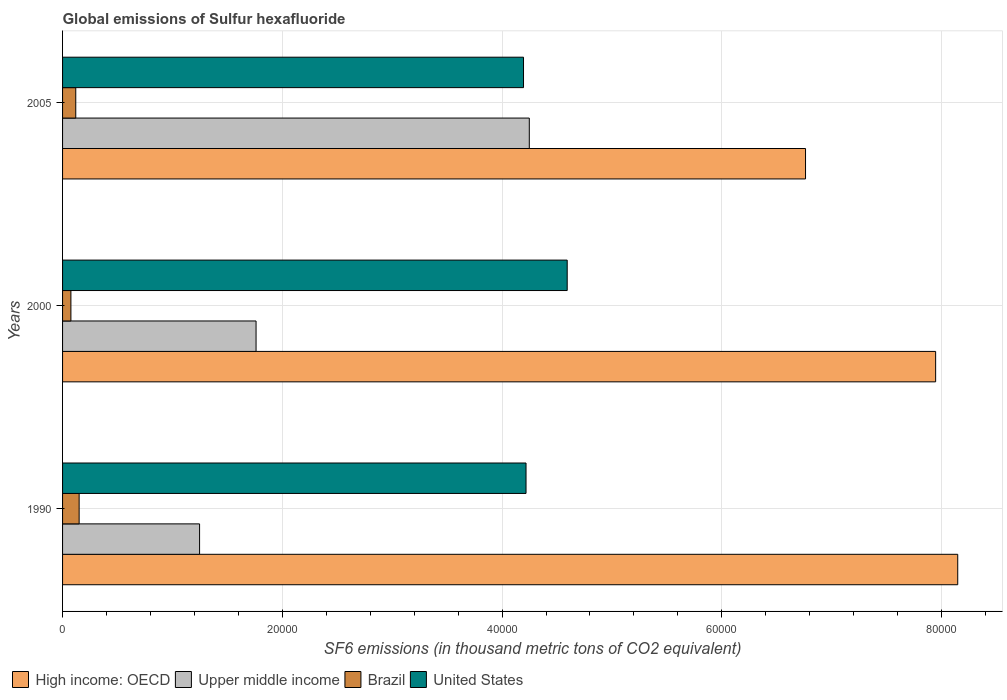How many different coloured bars are there?
Your answer should be compact. 4. Are the number of bars on each tick of the Y-axis equal?
Provide a short and direct response. Yes. What is the global emissions of Sulfur hexafluoride in Upper middle income in 2005?
Make the answer very short. 4.25e+04. Across all years, what is the maximum global emissions of Sulfur hexafluoride in United States?
Ensure brevity in your answer.  4.59e+04. Across all years, what is the minimum global emissions of Sulfur hexafluoride in High income: OECD?
Provide a succinct answer. 6.76e+04. In which year was the global emissions of Sulfur hexafluoride in Upper middle income maximum?
Offer a very short reply. 2005. In which year was the global emissions of Sulfur hexafluoride in United States minimum?
Your answer should be very brief. 2005. What is the total global emissions of Sulfur hexafluoride in Brazil in the graph?
Provide a short and direct response. 3468.6. What is the difference between the global emissions of Sulfur hexafluoride in United States in 2000 and that in 2005?
Your response must be concise. 3977.2. What is the difference between the global emissions of Sulfur hexafluoride in United States in 2005 and the global emissions of Sulfur hexafluoride in Upper middle income in 2000?
Offer a terse response. 2.43e+04. What is the average global emissions of Sulfur hexafluoride in Brazil per year?
Your answer should be compact. 1156.2. In the year 2000, what is the difference between the global emissions of Sulfur hexafluoride in Brazil and global emissions of Sulfur hexafluoride in United States?
Your response must be concise. -4.52e+04. In how many years, is the global emissions of Sulfur hexafluoride in High income: OECD greater than 8000 thousand metric tons?
Provide a short and direct response. 3. What is the ratio of the global emissions of Sulfur hexafluoride in High income: OECD in 1990 to that in 2005?
Offer a terse response. 1.2. Is the global emissions of Sulfur hexafluoride in United States in 1990 less than that in 2000?
Provide a short and direct response. Yes. Is the difference between the global emissions of Sulfur hexafluoride in Brazil in 1990 and 2000 greater than the difference between the global emissions of Sulfur hexafluoride in United States in 1990 and 2000?
Your response must be concise. Yes. What is the difference between the highest and the second highest global emissions of Sulfur hexafluoride in Upper middle income?
Keep it short and to the point. 2.49e+04. What is the difference between the highest and the lowest global emissions of Sulfur hexafluoride in United States?
Provide a short and direct response. 3977.2. What does the 4th bar from the top in 1990 represents?
Provide a succinct answer. High income: OECD. What does the 3rd bar from the bottom in 2000 represents?
Offer a terse response. Brazil. Is it the case that in every year, the sum of the global emissions of Sulfur hexafluoride in High income: OECD and global emissions of Sulfur hexafluoride in Upper middle income is greater than the global emissions of Sulfur hexafluoride in Brazil?
Keep it short and to the point. Yes. How many bars are there?
Your response must be concise. 12. Are all the bars in the graph horizontal?
Your answer should be very brief. Yes. How many years are there in the graph?
Offer a very short reply. 3. What is the difference between two consecutive major ticks on the X-axis?
Ensure brevity in your answer.  2.00e+04. Where does the legend appear in the graph?
Offer a terse response. Bottom left. How many legend labels are there?
Keep it short and to the point. 4. What is the title of the graph?
Give a very brief answer. Global emissions of Sulfur hexafluoride. Does "Ukraine" appear as one of the legend labels in the graph?
Provide a short and direct response. No. What is the label or title of the X-axis?
Give a very brief answer. SF6 emissions (in thousand metric tons of CO2 equivalent). What is the label or title of the Y-axis?
Provide a short and direct response. Years. What is the SF6 emissions (in thousand metric tons of CO2 equivalent) in High income: OECD in 1990?
Your response must be concise. 8.15e+04. What is the SF6 emissions (in thousand metric tons of CO2 equivalent) of Upper middle income in 1990?
Your answer should be compact. 1.25e+04. What is the SF6 emissions (in thousand metric tons of CO2 equivalent) of Brazil in 1990?
Make the answer very short. 1507.9. What is the SF6 emissions (in thousand metric tons of CO2 equivalent) of United States in 1990?
Give a very brief answer. 4.22e+04. What is the SF6 emissions (in thousand metric tons of CO2 equivalent) of High income: OECD in 2000?
Make the answer very short. 7.95e+04. What is the SF6 emissions (in thousand metric tons of CO2 equivalent) in Upper middle income in 2000?
Provide a short and direct response. 1.76e+04. What is the SF6 emissions (in thousand metric tons of CO2 equivalent) of Brazil in 2000?
Your answer should be very brief. 758.7. What is the SF6 emissions (in thousand metric tons of CO2 equivalent) of United States in 2000?
Offer a terse response. 4.59e+04. What is the SF6 emissions (in thousand metric tons of CO2 equivalent) in High income: OECD in 2005?
Your answer should be compact. 6.76e+04. What is the SF6 emissions (in thousand metric tons of CO2 equivalent) in Upper middle income in 2005?
Ensure brevity in your answer.  4.25e+04. What is the SF6 emissions (in thousand metric tons of CO2 equivalent) in Brazil in 2005?
Your answer should be very brief. 1202. What is the SF6 emissions (in thousand metric tons of CO2 equivalent) of United States in 2005?
Offer a terse response. 4.20e+04. Across all years, what is the maximum SF6 emissions (in thousand metric tons of CO2 equivalent) of High income: OECD?
Offer a terse response. 8.15e+04. Across all years, what is the maximum SF6 emissions (in thousand metric tons of CO2 equivalent) of Upper middle income?
Offer a terse response. 4.25e+04. Across all years, what is the maximum SF6 emissions (in thousand metric tons of CO2 equivalent) of Brazil?
Keep it short and to the point. 1507.9. Across all years, what is the maximum SF6 emissions (in thousand metric tons of CO2 equivalent) in United States?
Your response must be concise. 4.59e+04. Across all years, what is the minimum SF6 emissions (in thousand metric tons of CO2 equivalent) of High income: OECD?
Your answer should be very brief. 6.76e+04. Across all years, what is the minimum SF6 emissions (in thousand metric tons of CO2 equivalent) of Upper middle income?
Make the answer very short. 1.25e+04. Across all years, what is the minimum SF6 emissions (in thousand metric tons of CO2 equivalent) in Brazil?
Offer a terse response. 758.7. Across all years, what is the minimum SF6 emissions (in thousand metric tons of CO2 equivalent) of United States?
Keep it short and to the point. 4.20e+04. What is the total SF6 emissions (in thousand metric tons of CO2 equivalent) in High income: OECD in the graph?
Offer a terse response. 2.29e+05. What is the total SF6 emissions (in thousand metric tons of CO2 equivalent) of Upper middle income in the graph?
Your response must be concise. 7.26e+04. What is the total SF6 emissions (in thousand metric tons of CO2 equivalent) in Brazil in the graph?
Offer a terse response. 3468.6. What is the total SF6 emissions (in thousand metric tons of CO2 equivalent) in United States in the graph?
Make the answer very short. 1.30e+05. What is the difference between the SF6 emissions (in thousand metric tons of CO2 equivalent) in High income: OECD in 1990 and that in 2000?
Provide a short and direct response. 2011.1. What is the difference between the SF6 emissions (in thousand metric tons of CO2 equivalent) of Upper middle income in 1990 and that in 2000?
Make the answer very short. -5140.8. What is the difference between the SF6 emissions (in thousand metric tons of CO2 equivalent) of Brazil in 1990 and that in 2000?
Keep it short and to the point. 749.2. What is the difference between the SF6 emissions (in thousand metric tons of CO2 equivalent) of United States in 1990 and that in 2000?
Offer a very short reply. -3747.6. What is the difference between the SF6 emissions (in thousand metric tons of CO2 equivalent) of High income: OECD in 1990 and that in 2005?
Give a very brief answer. 1.39e+04. What is the difference between the SF6 emissions (in thousand metric tons of CO2 equivalent) of Upper middle income in 1990 and that in 2005?
Your answer should be compact. -3.00e+04. What is the difference between the SF6 emissions (in thousand metric tons of CO2 equivalent) in Brazil in 1990 and that in 2005?
Your response must be concise. 305.9. What is the difference between the SF6 emissions (in thousand metric tons of CO2 equivalent) in United States in 1990 and that in 2005?
Offer a very short reply. 229.6. What is the difference between the SF6 emissions (in thousand metric tons of CO2 equivalent) in High income: OECD in 2000 and that in 2005?
Provide a succinct answer. 1.18e+04. What is the difference between the SF6 emissions (in thousand metric tons of CO2 equivalent) in Upper middle income in 2000 and that in 2005?
Provide a short and direct response. -2.49e+04. What is the difference between the SF6 emissions (in thousand metric tons of CO2 equivalent) in Brazil in 2000 and that in 2005?
Your answer should be compact. -443.3. What is the difference between the SF6 emissions (in thousand metric tons of CO2 equivalent) in United States in 2000 and that in 2005?
Your answer should be compact. 3977.2. What is the difference between the SF6 emissions (in thousand metric tons of CO2 equivalent) in High income: OECD in 1990 and the SF6 emissions (in thousand metric tons of CO2 equivalent) in Upper middle income in 2000?
Keep it short and to the point. 6.39e+04. What is the difference between the SF6 emissions (in thousand metric tons of CO2 equivalent) in High income: OECD in 1990 and the SF6 emissions (in thousand metric tons of CO2 equivalent) in Brazil in 2000?
Your answer should be compact. 8.07e+04. What is the difference between the SF6 emissions (in thousand metric tons of CO2 equivalent) in High income: OECD in 1990 and the SF6 emissions (in thousand metric tons of CO2 equivalent) in United States in 2000?
Offer a very short reply. 3.55e+04. What is the difference between the SF6 emissions (in thousand metric tons of CO2 equivalent) of Upper middle income in 1990 and the SF6 emissions (in thousand metric tons of CO2 equivalent) of Brazil in 2000?
Offer a terse response. 1.17e+04. What is the difference between the SF6 emissions (in thousand metric tons of CO2 equivalent) of Upper middle income in 1990 and the SF6 emissions (in thousand metric tons of CO2 equivalent) of United States in 2000?
Offer a terse response. -3.35e+04. What is the difference between the SF6 emissions (in thousand metric tons of CO2 equivalent) of Brazil in 1990 and the SF6 emissions (in thousand metric tons of CO2 equivalent) of United States in 2000?
Give a very brief answer. -4.44e+04. What is the difference between the SF6 emissions (in thousand metric tons of CO2 equivalent) of High income: OECD in 1990 and the SF6 emissions (in thousand metric tons of CO2 equivalent) of Upper middle income in 2005?
Ensure brevity in your answer.  3.90e+04. What is the difference between the SF6 emissions (in thousand metric tons of CO2 equivalent) of High income: OECD in 1990 and the SF6 emissions (in thousand metric tons of CO2 equivalent) of Brazil in 2005?
Ensure brevity in your answer.  8.03e+04. What is the difference between the SF6 emissions (in thousand metric tons of CO2 equivalent) of High income: OECD in 1990 and the SF6 emissions (in thousand metric tons of CO2 equivalent) of United States in 2005?
Provide a short and direct response. 3.95e+04. What is the difference between the SF6 emissions (in thousand metric tons of CO2 equivalent) of Upper middle income in 1990 and the SF6 emissions (in thousand metric tons of CO2 equivalent) of Brazil in 2005?
Ensure brevity in your answer.  1.13e+04. What is the difference between the SF6 emissions (in thousand metric tons of CO2 equivalent) in Upper middle income in 1990 and the SF6 emissions (in thousand metric tons of CO2 equivalent) in United States in 2005?
Offer a terse response. -2.95e+04. What is the difference between the SF6 emissions (in thousand metric tons of CO2 equivalent) of Brazil in 1990 and the SF6 emissions (in thousand metric tons of CO2 equivalent) of United States in 2005?
Ensure brevity in your answer.  -4.04e+04. What is the difference between the SF6 emissions (in thousand metric tons of CO2 equivalent) in High income: OECD in 2000 and the SF6 emissions (in thousand metric tons of CO2 equivalent) in Upper middle income in 2005?
Ensure brevity in your answer.  3.70e+04. What is the difference between the SF6 emissions (in thousand metric tons of CO2 equivalent) of High income: OECD in 2000 and the SF6 emissions (in thousand metric tons of CO2 equivalent) of Brazil in 2005?
Your answer should be compact. 7.83e+04. What is the difference between the SF6 emissions (in thousand metric tons of CO2 equivalent) in High income: OECD in 2000 and the SF6 emissions (in thousand metric tons of CO2 equivalent) in United States in 2005?
Provide a short and direct response. 3.75e+04. What is the difference between the SF6 emissions (in thousand metric tons of CO2 equivalent) in Upper middle income in 2000 and the SF6 emissions (in thousand metric tons of CO2 equivalent) in Brazil in 2005?
Your answer should be compact. 1.64e+04. What is the difference between the SF6 emissions (in thousand metric tons of CO2 equivalent) in Upper middle income in 2000 and the SF6 emissions (in thousand metric tons of CO2 equivalent) in United States in 2005?
Your answer should be very brief. -2.43e+04. What is the difference between the SF6 emissions (in thousand metric tons of CO2 equivalent) in Brazil in 2000 and the SF6 emissions (in thousand metric tons of CO2 equivalent) in United States in 2005?
Offer a very short reply. -4.12e+04. What is the average SF6 emissions (in thousand metric tons of CO2 equivalent) in High income: OECD per year?
Your response must be concise. 7.62e+04. What is the average SF6 emissions (in thousand metric tons of CO2 equivalent) in Upper middle income per year?
Make the answer very short. 2.42e+04. What is the average SF6 emissions (in thousand metric tons of CO2 equivalent) in Brazil per year?
Offer a very short reply. 1156.2. What is the average SF6 emissions (in thousand metric tons of CO2 equivalent) in United States per year?
Give a very brief answer. 4.34e+04. In the year 1990, what is the difference between the SF6 emissions (in thousand metric tons of CO2 equivalent) in High income: OECD and SF6 emissions (in thousand metric tons of CO2 equivalent) in Upper middle income?
Make the answer very short. 6.90e+04. In the year 1990, what is the difference between the SF6 emissions (in thousand metric tons of CO2 equivalent) of High income: OECD and SF6 emissions (in thousand metric tons of CO2 equivalent) of Brazil?
Keep it short and to the point. 8.00e+04. In the year 1990, what is the difference between the SF6 emissions (in thousand metric tons of CO2 equivalent) of High income: OECD and SF6 emissions (in thousand metric tons of CO2 equivalent) of United States?
Offer a terse response. 3.93e+04. In the year 1990, what is the difference between the SF6 emissions (in thousand metric tons of CO2 equivalent) of Upper middle income and SF6 emissions (in thousand metric tons of CO2 equivalent) of Brazil?
Your answer should be compact. 1.10e+04. In the year 1990, what is the difference between the SF6 emissions (in thousand metric tons of CO2 equivalent) of Upper middle income and SF6 emissions (in thousand metric tons of CO2 equivalent) of United States?
Your response must be concise. -2.97e+04. In the year 1990, what is the difference between the SF6 emissions (in thousand metric tons of CO2 equivalent) in Brazil and SF6 emissions (in thousand metric tons of CO2 equivalent) in United States?
Offer a very short reply. -4.07e+04. In the year 2000, what is the difference between the SF6 emissions (in thousand metric tons of CO2 equivalent) in High income: OECD and SF6 emissions (in thousand metric tons of CO2 equivalent) in Upper middle income?
Keep it short and to the point. 6.19e+04. In the year 2000, what is the difference between the SF6 emissions (in thousand metric tons of CO2 equivalent) in High income: OECD and SF6 emissions (in thousand metric tons of CO2 equivalent) in Brazil?
Your response must be concise. 7.87e+04. In the year 2000, what is the difference between the SF6 emissions (in thousand metric tons of CO2 equivalent) in High income: OECD and SF6 emissions (in thousand metric tons of CO2 equivalent) in United States?
Give a very brief answer. 3.35e+04. In the year 2000, what is the difference between the SF6 emissions (in thousand metric tons of CO2 equivalent) in Upper middle income and SF6 emissions (in thousand metric tons of CO2 equivalent) in Brazil?
Your answer should be very brief. 1.69e+04. In the year 2000, what is the difference between the SF6 emissions (in thousand metric tons of CO2 equivalent) in Upper middle income and SF6 emissions (in thousand metric tons of CO2 equivalent) in United States?
Provide a succinct answer. -2.83e+04. In the year 2000, what is the difference between the SF6 emissions (in thousand metric tons of CO2 equivalent) in Brazil and SF6 emissions (in thousand metric tons of CO2 equivalent) in United States?
Make the answer very short. -4.52e+04. In the year 2005, what is the difference between the SF6 emissions (in thousand metric tons of CO2 equivalent) in High income: OECD and SF6 emissions (in thousand metric tons of CO2 equivalent) in Upper middle income?
Your response must be concise. 2.51e+04. In the year 2005, what is the difference between the SF6 emissions (in thousand metric tons of CO2 equivalent) of High income: OECD and SF6 emissions (in thousand metric tons of CO2 equivalent) of Brazil?
Give a very brief answer. 6.64e+04. In the year 2005, what is the difference between the SF6 emissions (in thousand metric tons of CO2 equivalent) in High income: OECD and SF6 emissions (in thousand metric tons of CO2 equivalent) in United States?
Offer a very short reply. 2.57e+04. In the year 2005, what is the difference between the SF6 emissions (in thousand metric tons of CO2 equivalent) in Upper middle income and SF6 emissions (in thousand metric tons of CO2 equivalent) in Brazil?
Keep it short and to the point. 4.13e+04. In the year 2005, what is the difference between the SF6 emissions (in thousand metric tons of CO2 equivalent) in Upper middle income and SF6 emissions (in thousand metric tons of CO2 equivalent) in United States?
Your answer should be very brief. 526.13. In the year 2005, what is the difference between the SF6 emissions (in thousand metric tons of CO2 equivalent) of Brazil and SF6 emissions (in thousand metric tons of CO2 equivalent) of United States?
Offer a terse response. -4.08e+04. What is the ratio of the SF6 emissions (in thousand metric tons of CO2 equivalent) of High income: OECD in 1990 to that in 2000?
Your answer should be very brief. 1.03. What is the ratio of the SF6 emissions (in thousand metric tons of CO2 equivalent) of Upper middle income in 1990 to that in 2000?
Ensure brevity in your answer.  0.71. What is the ratio of the SF6 emissions (in thousand metric tons of CO2 equivalent) of Brazil in 1990 to that in 2000?
Give a very brief answer. 1.99. What is the ratio of the SF6 emissions (in thousand metric tons of CO2 equivalent) in United States in 1990 to that in 2000?
Offer a terse response. 0.92. What is the ratio of the SF6 emissions (in thousand metric tons of CO2 equivalent) of High income: OECD in 1990 to that in 2005?
Provide a short and direct response. 1.2. What is the ratio of the SF6 emissions (in thousand metric tons of CO2 equivalent) in Upper middle income in 1990 to that in 2005?
Provide a succinct answer. 0.29. What is the ratio of the SF6 emissions (in thousand metric tons of CO2 equivalent) in Brazil in 1990 to that in 2005?
Provide a succinct answer. 1.25. What is the ratio of the SF6 emissions (in thousand metric tons of CO2 equivalent) of High income: OECD in 2000 to that in 2005?
Provide a short and direct response. 1.18. What is the ratio of the SF6 emissions (in thousand metric tons of CO2 equivalent) in Upper middle income in 2000 to that in 2005?
Ensure brevity in your answer.  0.41. What is the ratio of the SF6 emissions (in thousand metric tons of CO2 equivalent) in Brazil in 2000 to that in 2005?
Make the answer very short. 0.63. What is the ratio of the SF6 emissions (in thousand metric tons of CO2 equivalent) in United States in 2000 to that in 2005?
Your answer should be very brief. 1.09. What is the difference between the highest and the second highest SF6 emissions (in thousand metric tons of CO2 equivalent) of High income: OECD?
Offer a very short reply. 2011.1. What is the difference between the highest and the second highest SF6 emissions (in thousand metric tons of CO2 equivalent) of Upper middle income?
Offer a very short reply. 2.49e+04. What is the difference between the highest and the second highest SF6 emissions (in thousand metric tons of CO2 equivalent) in Brazil?
Your response must be concise. 305.9. What is the difference between the highest and the second highest SF6 emissions (in thousand metric tons of CO2 equivalent) in United States?
Offer a very short reply. 3747.6. What is the difference between the highest and the lowest SF6 emissions (in thousand metric tons of CO2 equivalent) of High income: OECD?
Offer a terse response. 1.39e+04. What is the difference between the highest and the lowest SF6 emissions (in thousand metric tons of CO2 equivalent) in Upper middle income?
Give a very brief answer. 3.00e+04. What is the difference between the highest and the lowest SF6 emissions (in thousand metric tons of CO2 equivalent) of Brazil?
Keep it short and to the point. 749.2. What is the difference between the highest and the lowest SF6 emissions (in thousand metric tons of CO2 equivalent) in United States?
Offer a very short reply. 3977.2. 